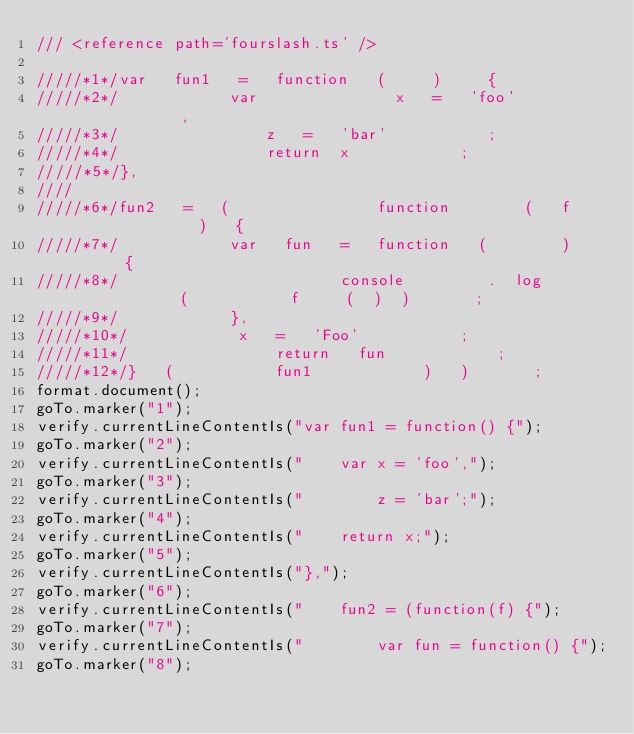Convert code to text. <code><loc_0><loc_0><loc_500><loc_500><_TypeScript_>/// <reference path='fourslash.ts' />

/////*1*/var   fun1   =   function   (     )     {
/////*2*/            var               x   =   'foo'             ,
/////*3*/                z   =   'bar'           ;
/////*4*/                return  x            ;
/////*5*/},
////
/////*6*/fun2   =   (                function        (   f               )   {
/////*7*/            var   fun   =   function   (        )       {
/////*8*/                        console         .  log             (           f     (  )  )       ;
/////*9*/            },
/////*10*/            x   =   'Foo'           ;
/////*11*/                return   fun            ;
/////*12*/}   (           fun1            )   )       ;
format.document();
goTo.marker("1");
verify.currentLineContentIs("var fun1 = function() {");
goTo.marker("2");
verify.currentLineContentIs("    var x = 'foo',");
goTo.marker("3");
verify.currentLineContentIs("        z = 'bar';");
goTo.marker("4");
verify.currentLineContentIs("    return x;");
goTo.marker("5");
verify.currentLineContentIs("},");
goTo.marker("6");
verify.currentLineContentIs("    fun2 = (function(f) {");
goTo.marker("7");
verify.currentLineContentIs("        var fun = function() {");
goTo.marker("8");</code> 